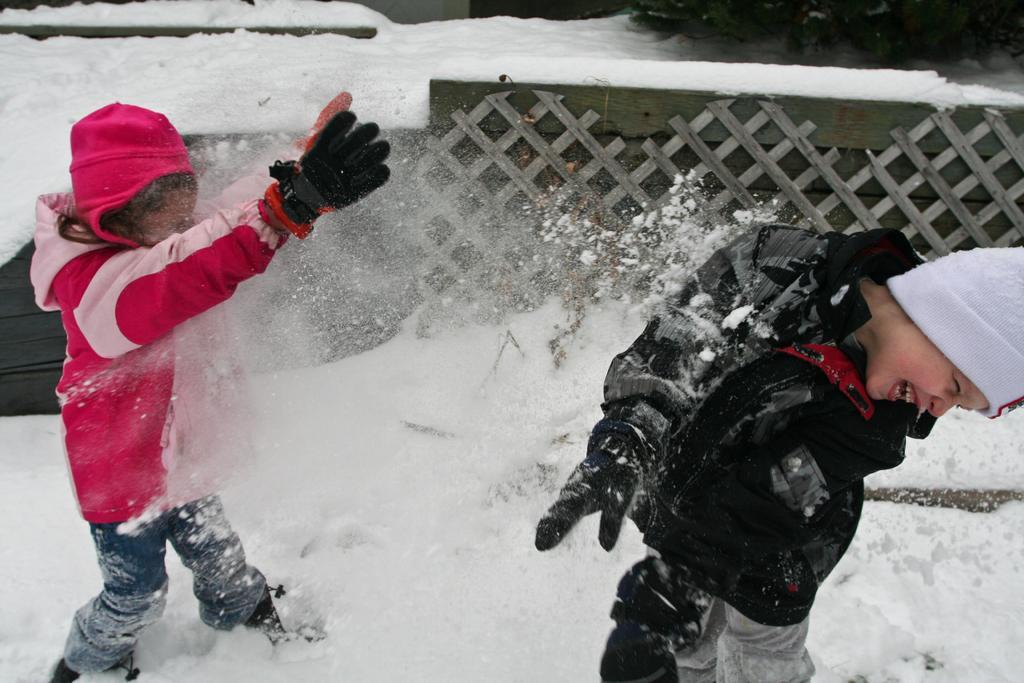In one or two sentences, can you explain what this image depicts? In this picture we can see there are two kids playing in the snow and behind the kids it is looking like a wooden fence. 